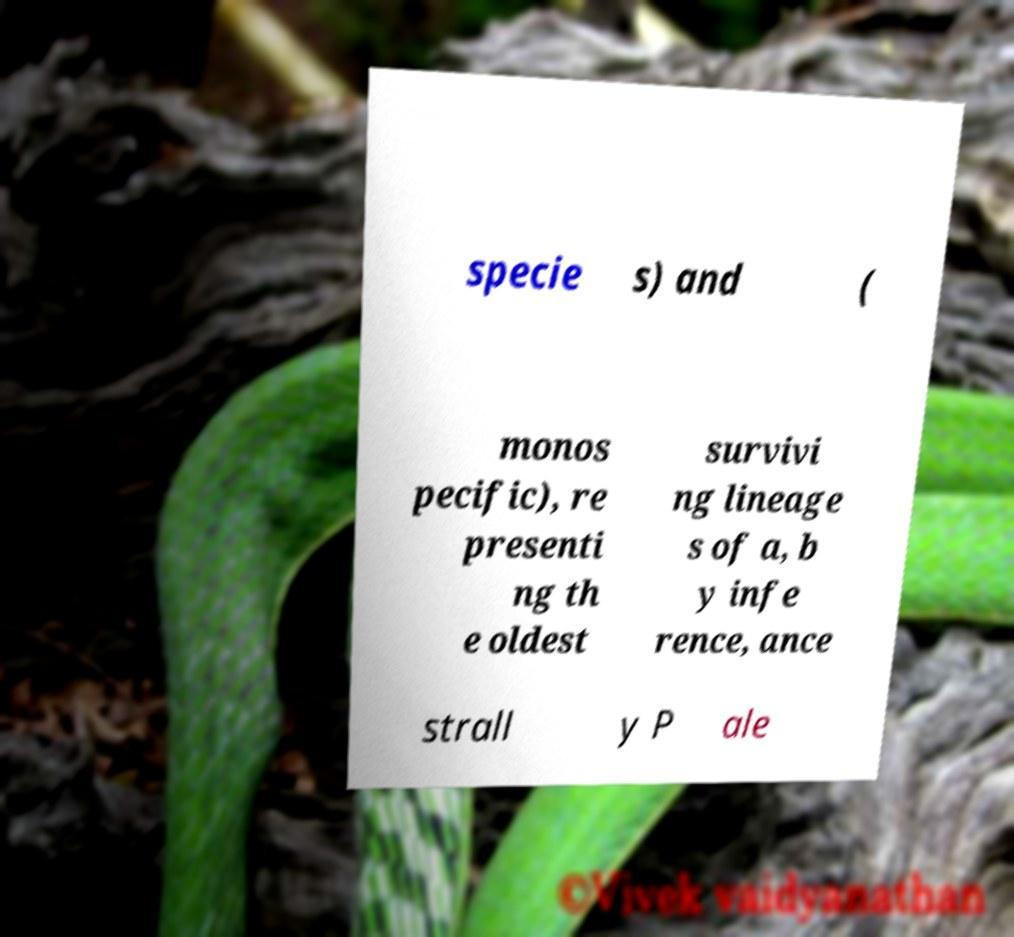Can you accurately transcribe the text from the provided image for me? specie s) and ( monos pecific), re presenti ng th e oldest survivi ng lineage s of a, b y infe rence, ance strall y P ale 